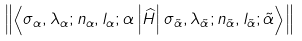Convert formula to latex. <formula><loc_0><loc_0><loc_500><loc_500>\left \| \left \langle \sigma _ { \alpha } , \lambda _ { \alpha } ; n _ { \alpha } , l _ { \alpha } ; \alpha \left | \widehat { H } \right | \sigma _ { \tilde { \alpha } } , \lambda _ { \tilde { \alpha } } ; n _ { \tilde { \alpha } } , l _ { \tilde { \alpha } } ; \tilde { \alpha } \right \rangle \right \|</formula> 